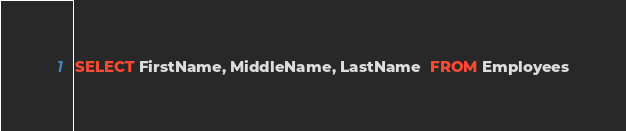Convert code to text. <code><loc_0><loc_0><loc_500><loc_500><_SQL_>SELECT FirstName, MiddleName, LastName  FROM Employees</code> 